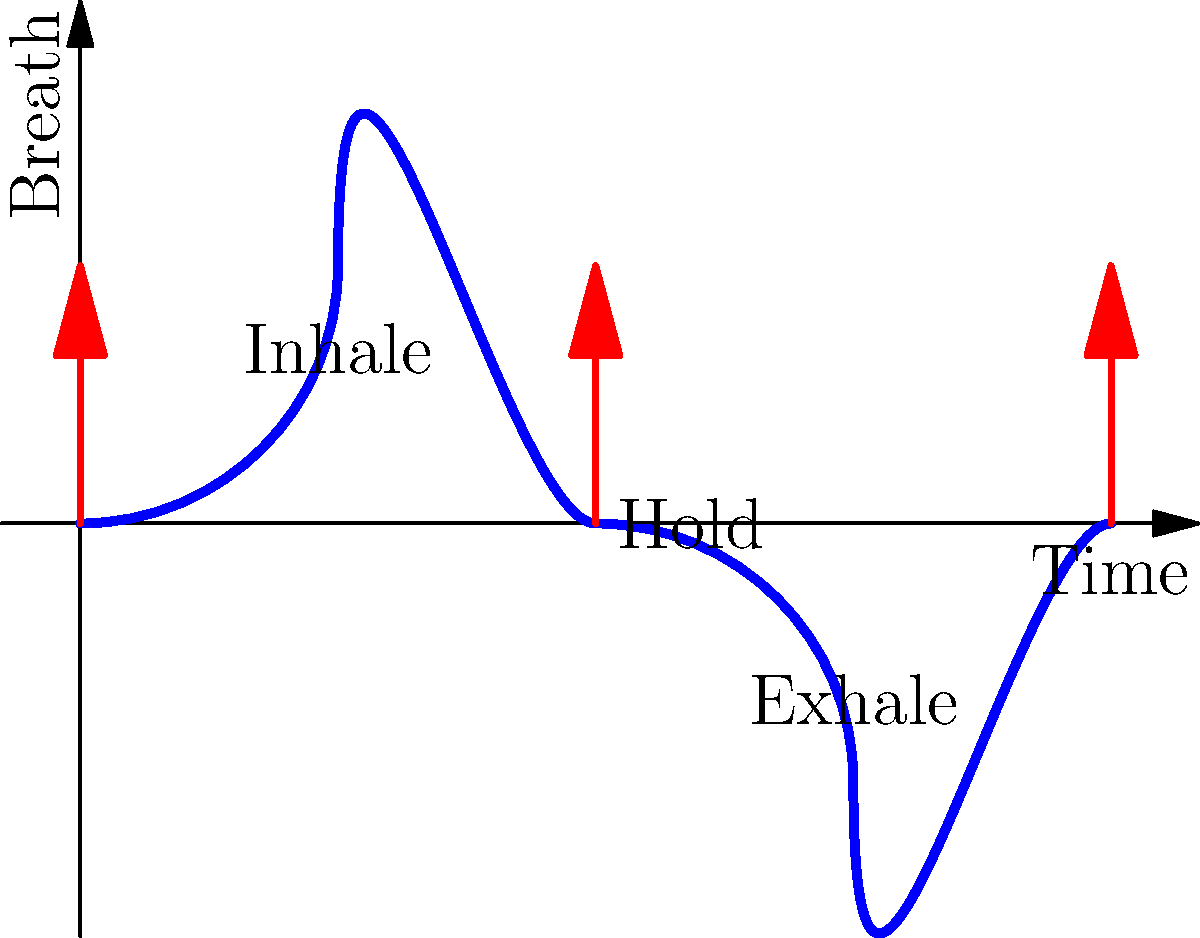Based on the illustrated breathing exercise, which phase of the mindfulness technique would be most effective for students to practice when feeling overwhelmed or anxious in the classroom? To answer this question, let's analyze each phase of the breathing exercise:

1. Inhale phase: This is where students take a deep breath in. While important, it's not the most calming part of the exercise.

2. Hold phase: This brief pause between inhaling and exhaling can help students focus, but it's not the most relaxing part.

3. Exhale phase: This is the most crucial phase for reducing anxiety and overwhelming feelings. Here's why:

   a. Physiologically, exhaling activates the parasympathetic nervous system, which helps to calm the body and mind.
   
   b. A longer exhale than inhale has been shown to reduce heart rate and blood pressure, further promoting relaxation.
   
   c. The act of slowly releasing breath gives students a sense of letting go of tension and stress.
   
   d. Focusing on the exhale provides a simple point of concentration, helping to quiet racing thoughts.

4. The complete cycle: While the entire breathing exercise is beneficial, the exhale phase is particularly effective for immediate stress relief.

Therefore, encouraging students to focus on and extend the exhale phase would be most effective when they're feeling overwhelmed or anxious in the classroom.
Answer: Exhale phase 